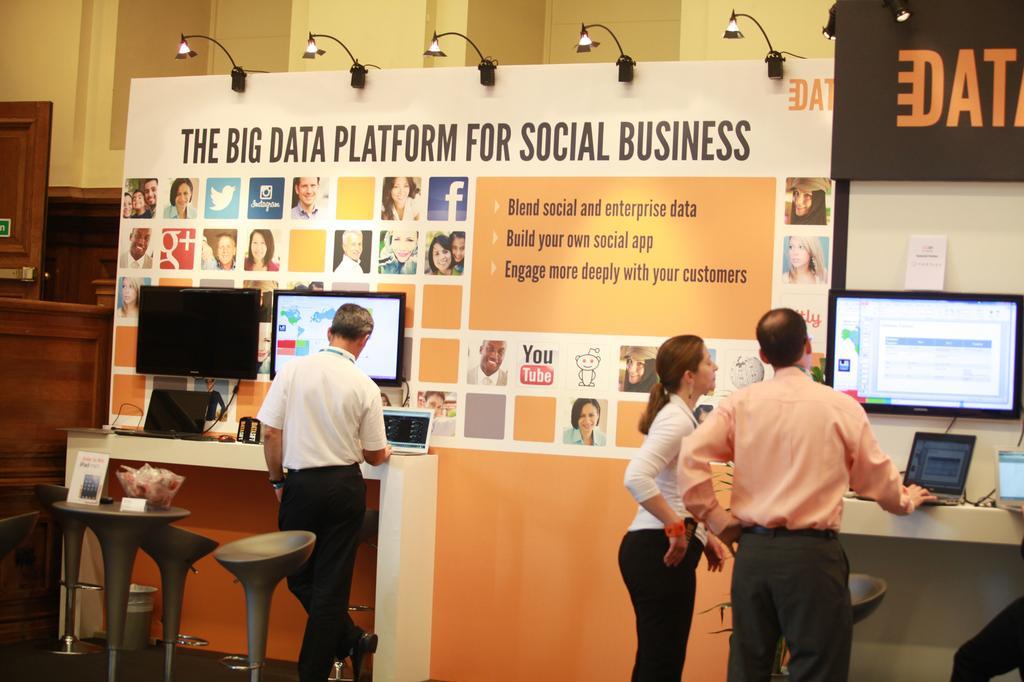Please provide a concise description of this image. In this picture there is a person standing. There are two other people standing. There is a laptop, television. There is a table. Calendar, basket is on the table. There is a chair. There is a poster and some lights. 